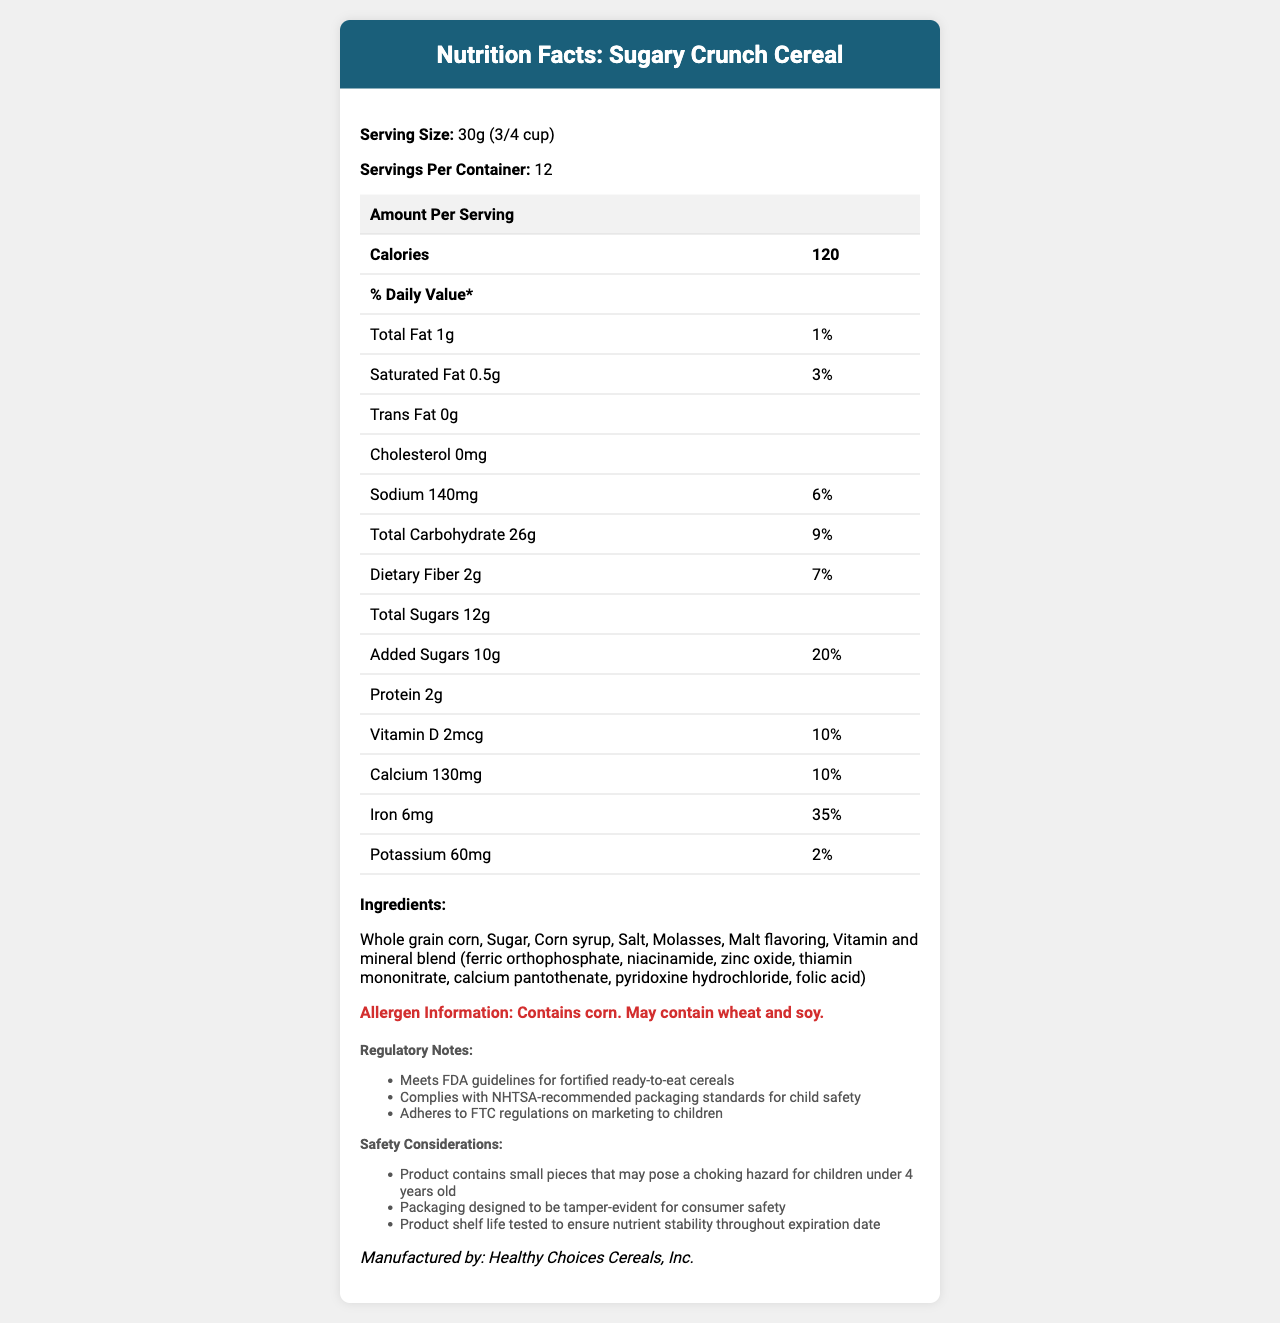what is the serving size of Sugary Crunch Cereal? The serving size is provided in the document under the product information section with the label "Serving Size."
Answer: 30g (3/4 cup) how many calories are in one serving of this cereal? The calories per serving are listed in the table under the section "Amount Per Serving" with the label "Calories."
Answer: 120 what percentage of the daily value of iron does one serving of Sugary Crunch Cereal provide? The iron content and its daily value percentage are listed under the vitamin and mineral content section in the document.
Answer: 35% how much added sugar is in one serving of Sugary Crunch Cereal? The amount of added sugars is specified in the table and highlighted with a daily value percentage of 20%.
Answer: 10g Which vitamin has the highest percentage of the daily value in one serving? The daily value percentages for all vitamins are listed in the document. Folate has the highest percentage at 50%.
Answer: Folate, 50% what are the first three ingredients listed for this cereal? The ingredients are listed in descending order of their amount. The first three are Whole grain corn, Sugar, and Corn syrup.
Answer: Whole grain corn, Sugar, Corn syrup what is the sodium content per serving of Sugary Crunch Cereal? The sodium content is listed in the table under the nutrient details with an associated daily value percentage.
Answer: 140mg does this cereal contain any potential allergens? The allergen information is mentioned in the document, stating that it contains corn and may contain wheat and soy.
Answer: Yes which vitamins are included in the vitamin and mineral blend? A. Vitamin A and Vitamin C B. Niacinamide, Zinc oxide, and Thiamin mononitrate C. Vitamin B12 and Folate The document lists the vitamin and mineral blend that includes niacinamide, zinc oxide, and thiamin mononitrate.
Answer: B how many servings are there per container of this cereal? The number of servings per container is listed in the product description.
Answer: 12 what safety considerations are noted for this cereal? A. May cause stomachache in some children B. Contains small pieces that may pose a choking hazard C. Can cause allergic reactions due to high corn content The document notes that there are safety considerations mentioning the product contains small pieces that may pose a choking hazard for children under 4 years old.
Answer: B is the cereal compliant with FDA guidelines for fortified cereals? The regulatory notes specify that the cereal meets FDA guidelines for fortified ready-to-eat cereals.
Answer: Yes summarize the key nutritional and safety information about Sugary Crunch Cereal. This summary captures the essential nutritional information such as calorie count, key vitamins and minerals, allergen warnings, safety considerations, compliance with regulations, and shelf life.
Answer: Sugary Crunch Cereal provides 120 calories per 30g serving, with key nutrients including Iron (35% daily value), Vitamin C (20% daily value), and Folate (50% daily value). The cereal contains 10g added sugars per serving, which is 20% of the daily value. The product may contain potential allergens like corn, wheat, and soy and poses a choking hazard for children under 4 years. It is FDA compliant and packed safely to ensure nutrient stability till the expiration date. what is the production date of this cereal? The document does not provide any information regarding the production date of Sugary Crunch Cereal.
Answer: Not enough information 